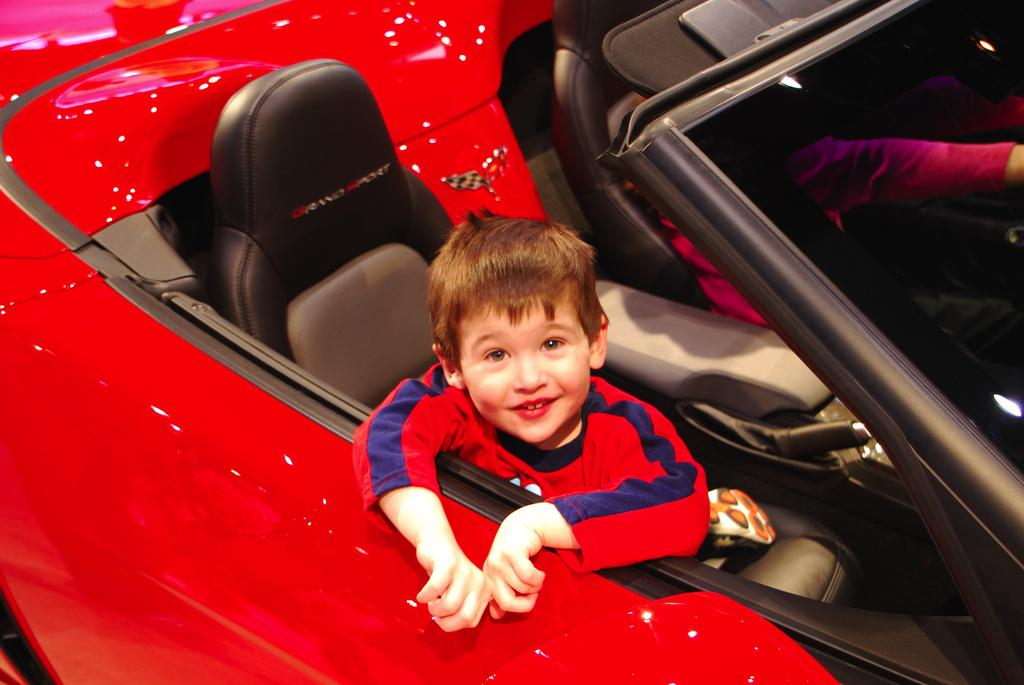Who is the main subject in the image? The main subject in the image is a boy. What is the boy doing in the image? The boy is sitting on a red color car and smiling. Is there anyone else in the image besides the boy? Yes, there is a person beside the boy. What type of pollution is visible in the image? There is no visible pollution in the image. What action is the boy performing in the image? The boy is sitting on a red color car and smiling, but we cannot determine a specific action from the provided facts. 